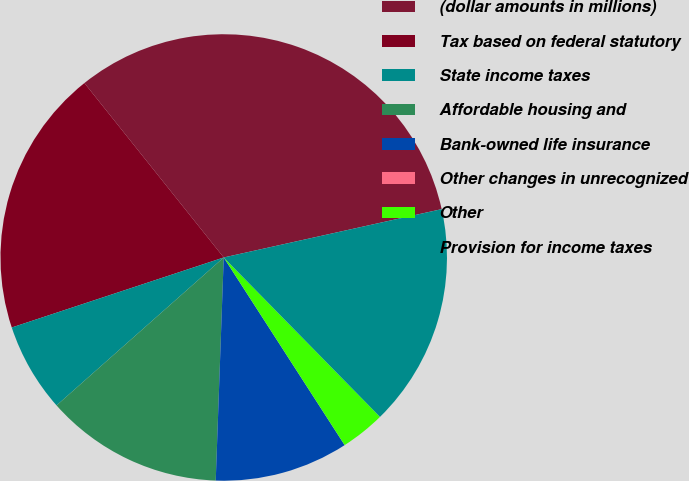<chart> <loc_0><loc_0><loc_500><loc_500><pie_chart><fcel>(dollar amounts in millions)<fcel>Tax based on federal statutory<fcel>State income taxes<fcel>Affordable housing and<fcel>Bank-owned life insurance<fcel>Other changes in unrecognized<fcel>Other<fcel>Provision for income taxes<nl><fcel>32.25%<fcel>19.35%<fcel>6.45%<fcel>12.9%<fcel>9.68%<fcel>0.0%<fcel>3.23%<fcel>16.13%<nl></chart> 